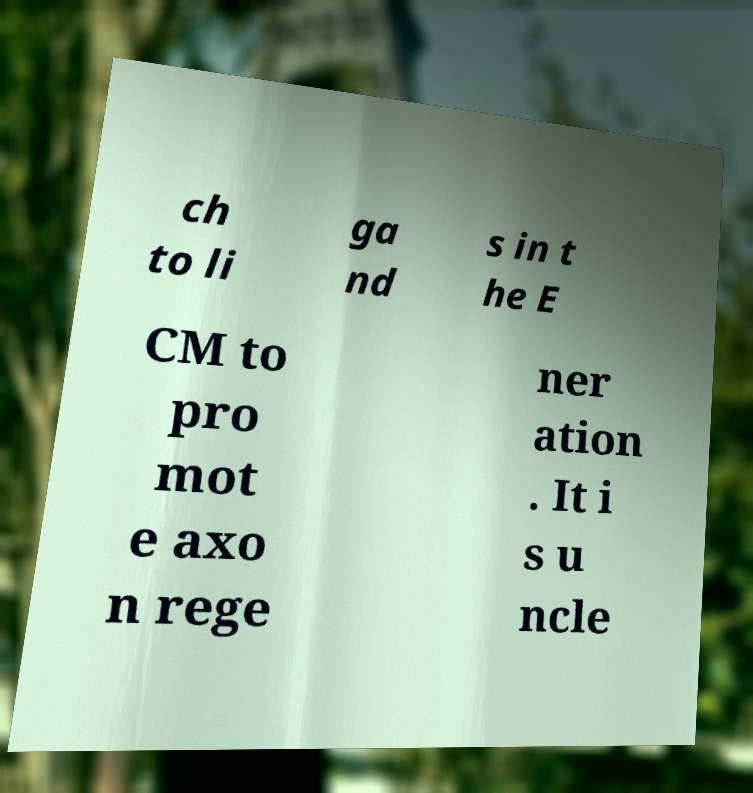What messages or text are displayed in this image? I need them in a readable, typed format. ch to li ga nd s in t he E CM to pro mot e axo n rege ner ation . It i s u ncle 